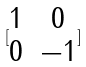Convert formula to latex. <formula><loc_0><loc_0><loc_500><loc_500>[ \begin{matrix} 1 & 0 \\ 0 & - 1 \end{matrix} ]</formula> 